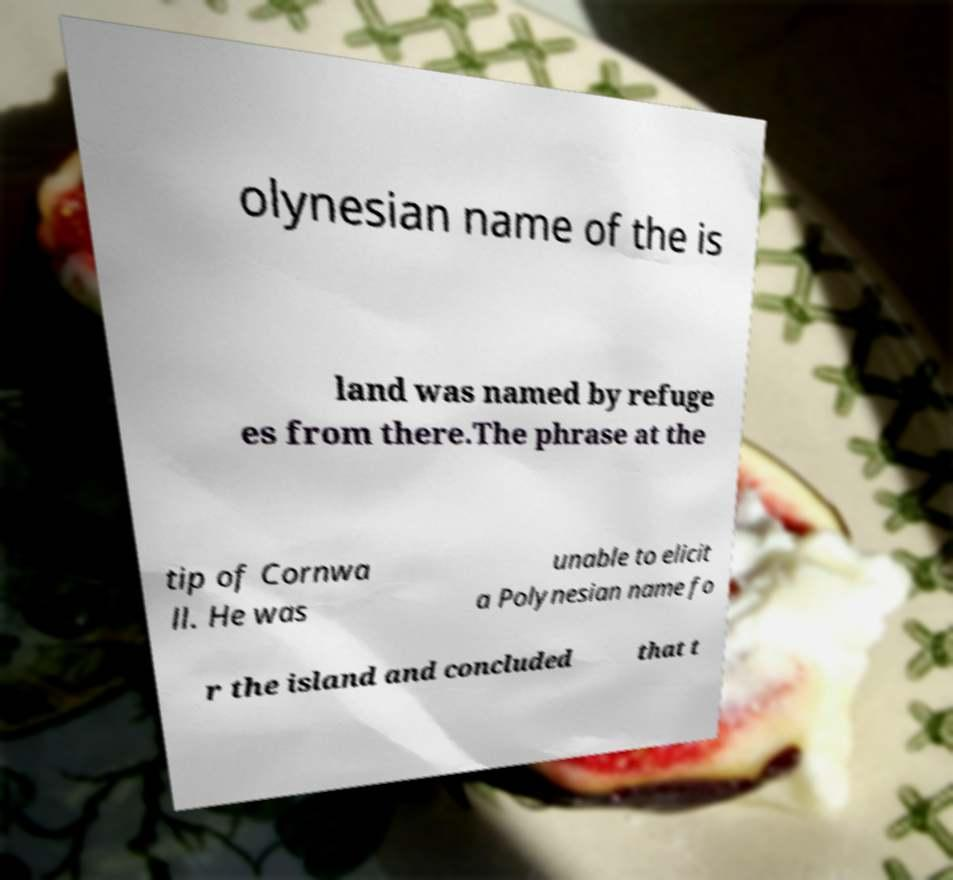Could you extract and type out the text from this image? olynesian name of the is land was named by refuge es from there.The phrase at the tip of Cornwa ll. He was unable to elicit a Polynesian name fo r the island and concluded that t 